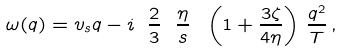Convert formula to latex. <formula><loc_0><loc_0><loc_500><loc_500>\omega ( q ) = v _ { s } q - i \ \frac { 2 } { 3 } \ \frac { \eta } { s } \ \left ( 1 + \frac { 3 \zeta } { 4 \eta } \right ) \, \frac { q ^ { 2 } } { T } \, ,</formula> 